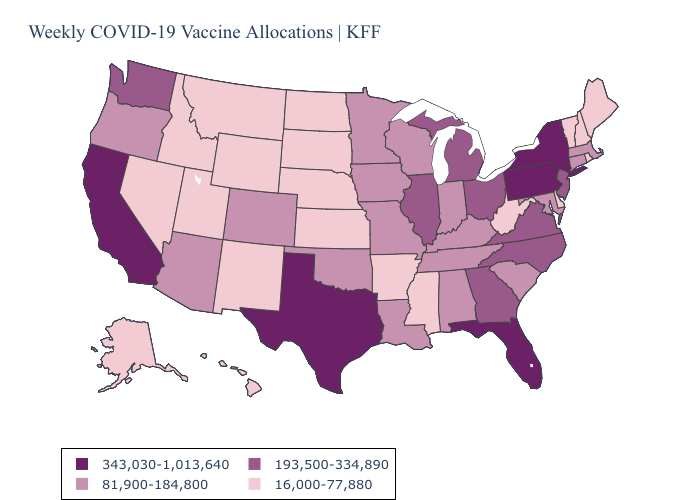Does Alabama have the lowest value in the USA?
Answer briefly. No. Name the states that have a value in the range 193,500-334,890?
Keep it brief. Georgia, Illinois, Michigan, New Jersey, North Carolina, Ohio, Virginia, Washington. Name the states that have a value in the range 16,000-77,880?
Answer briefly. Alaska, Arkansas, Delaware, Hawaii, Idaho, Kansas, Maine, Mississippi, Montana, Nebraska, Nevada, New Hampshire, New Mexico, North Dakota, Rhode Island, South Dakota, Utah, Vermont, West Virginia, Wyoming. Name the states that have a value in the range 343,030-1,013,640?
Keep it brief. California, Florida, New York, Pennsylvania, Texas. Name the states that have a value in the range 193,500-334,890?
Concise answer only. Georgia, Illinois, Michigan, New Jersey, North Carolina, Ohio, Virginia, Washington. Does Missouri have the lowest value in the MidWest?
Answer briefly. No. What is the lowest value in the USA?
Give a very brief answer. 16,000-77,880. Does Wyoming have the lowest value in the USA?
Answer briefly. Yes. Is the legend a continuous bar?
Concise answer only. No. Name the states that have a value in the range 16,000-77,880?
Give a very brief answer. Alaska, Arkansas, Delaware, Hawaii, Idaho, Kansas, Maine, Mississippi, Montana, Nebraska, Nevada, New Hampshire, New Mexico, North Dakota, Rhode Island, South Dakota, Utah, Vermont, West Virginia, Wyoming. Among the states that border Nevada , does Idaho have the lowest value?
Short answer required. Yes. What is the value of California?
Give a very brief answer. 343,030-1,013,640. Does Nebraska have the lowest value in the MidWest?
Keep it brief. Yes. Is the legend a continuous bar?
Keep it brief. No. Does Wisconsin have the highest value in the MidWest?
Write a very short answer. No. 